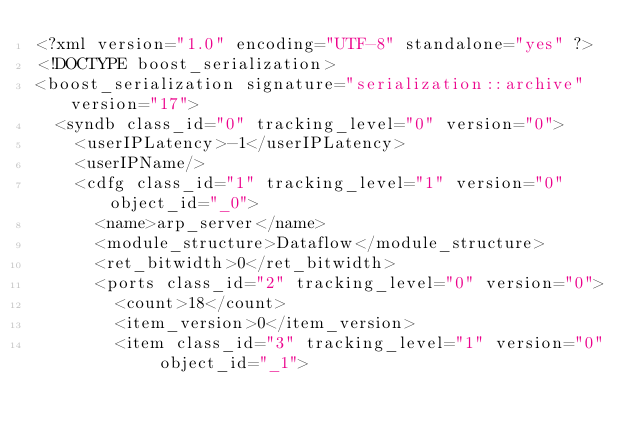<code> <loc_0><loc_0><loc_500><loc_500><_Ada_><?xml version="1.0" encoding="UTF-8" standalone="yes" ?>
<!DOCTYPE boost_serialization>
<boost_serialization signature="serialization::archive" version="17">
  <syndb class_id="0" tracking_level="0" version="0">
    <userIPLatency>-1</userIPLatency>
    <userIPName/>
    <cdfg class_id="1" tracking_level="1" version="0" object_id="_0">
      <name>arp_server</name>
      <module_structure>Dataflow</module_structure>
      <ret_bitwidth>0</ret_bitwidth>
      <ports class_id="2" tracking_level="0" version="0">
        <count>18</count>
        <item_version>0</item_version>
        <item class_id="3" tracking_level="1" version="0" object_id="_1"></code> 